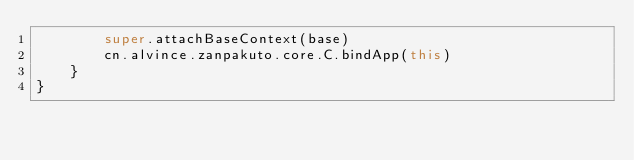<code> <loc_0><loc_0><loc_500><loc_500><_Kotlin_>        super.attachBaseContext(base)
        cn.alvince.zanpakuto.core.C.bindApp(this)
    }
}
</code> 